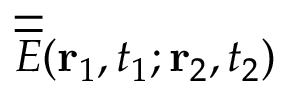Convert formula to latex. <formula><loc_0><loc_0><loc_500><loc_500>\overline { { \overline { E } } } ( { r } _ { 1 } , t _ { 1 } ; { r } _ { 2 } , t _ { 2 } )</formula> 